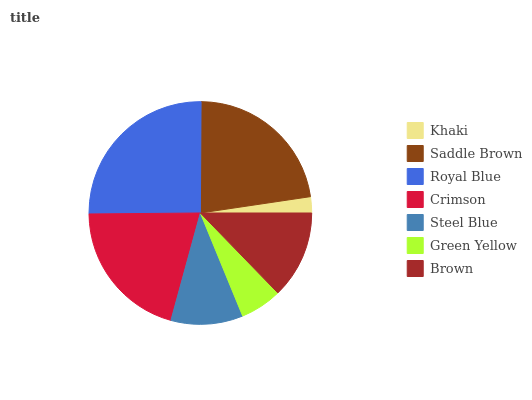Is Khaki the minimum?
Answer yes or no. Yes. Is Royal Blue the maximum?
Answer yes or no. Yes. Is Saddle Brown the minimum?
Answer yes or no. No. Is Saddle Brown the maximum?
Answer yes or no. No. Is Saddle Brown greater than Khaki?
Answer yes or no. Yes. Is Khaki less than Saddle Brown?
Answer yes or no. Yes. Is Khaki greater than Saddle Brown?
Answer yes or no. No. Is Saddle Brown less than Khaki?
Answer yes or no. No. Is Brown the high median?
Answer yes or no. Yes. Is Brown the low median?
Answer yes or no. Yes. Is Crimson the high median?
Answer yes or no. No. Is Saddle Brown the low median?
Answer yes or no. No. 